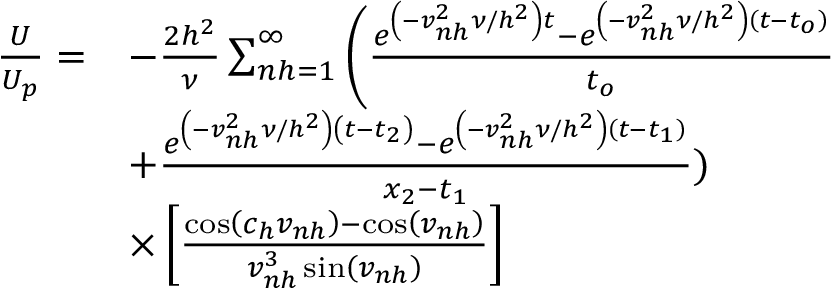Convert formula to latex. <formula><loc_0><loc_0><loc_500><loc_500>\begin{array} { r l } { \frac { U } { U _ { p } } = } & { - \frac { 2 h ^ { 2 } } { \nu } \sum _ { n h = 1 } ^ { \infty } \left ( \frac { e ^ { \left ( - v _ { n h } ^ { 2 } \nu / h ^ { 2 } \right ) t } - e ^ { \left ( - v _ { n h } ^ { 2 } \nu / h ^ { 2 } \right ) \left ( t - t _ { o } \right ) } } { t _ { o } } } \\ & { + \frac { e ^ { \left ( - v _ { n h } ^ { 2 } \nu / h ^ { 2 } \right ) \left ( t - t _ { 2 } \right ) } - e ^ { \left ( - v _ { n h } ^ { 2 } \nu / h ^ { 2 } \right ) \left ( t - t _ { 1 } \right ) } } { x _ { 2 } - t _ { 1 } } ) } \\ & { \times \left [ \frac { \cos \left ( c _ { h } v _ { n h } \right ) - \cos \left ( v _ { n h } \right ) } { v _ { n h } ^ { 3 } \sin \left ( v _ { n h } \right ) } \right ] } \end{array}</formula> 